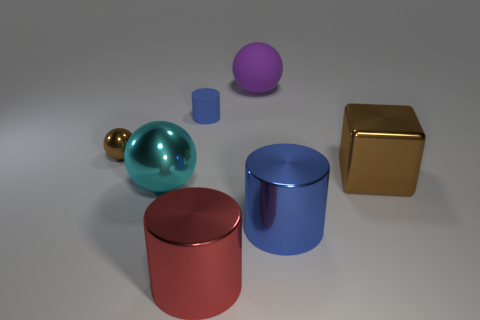Subtract all brown shiny balls. How many balls are left? 2 Add 2 green spheres. How many objects exist? 9 Subtract all purple spheres. How many spheres are left? 2 Subtract 2 spheres. How many spheres are left? 1 Subtract 0 green cubes. How many objects are left? 7 Subtract all cylinders. How many objects are left? 4 Subtract all green cubes. Subtract all brown balls. How many cubes are left? 1 Subtract all yellow cylinders. How many gray blocks are left? 0 Subtract all large red metallic things. Subtract all big shiny cylinders. How many objects are left? 4 Add 1 rubber cylinders. How many rubber cylinders are left? 2 